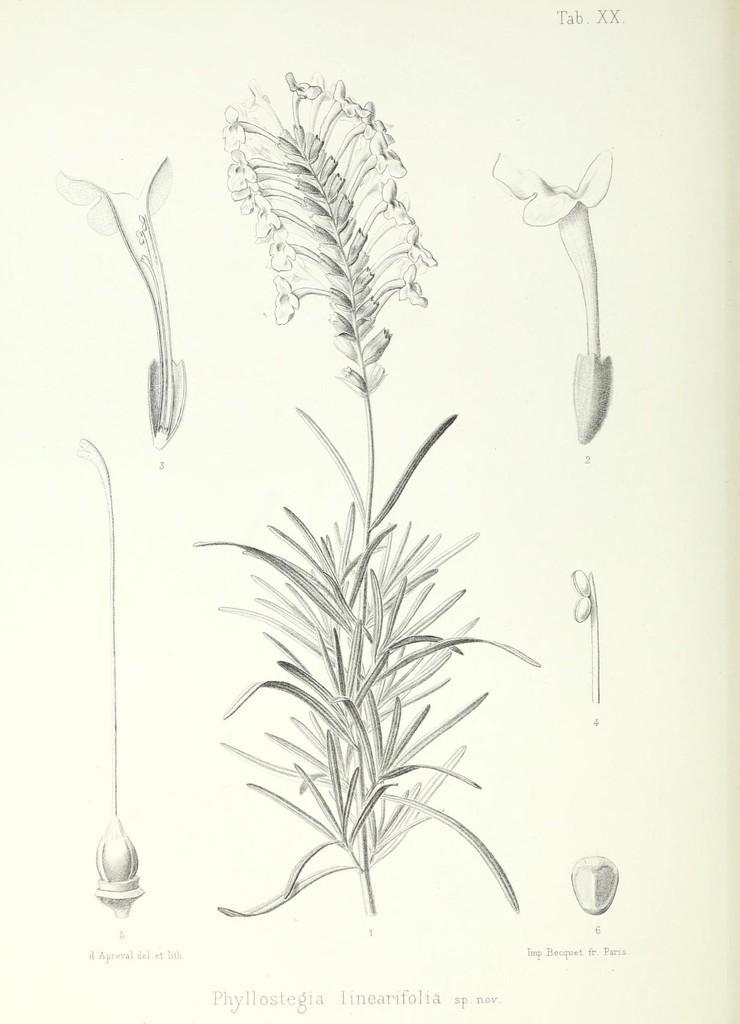Describe this image in one or two sentences. This is a paper with a drawing of a plant with flowers. Also we can see parts of a flower and something is written on the image. 